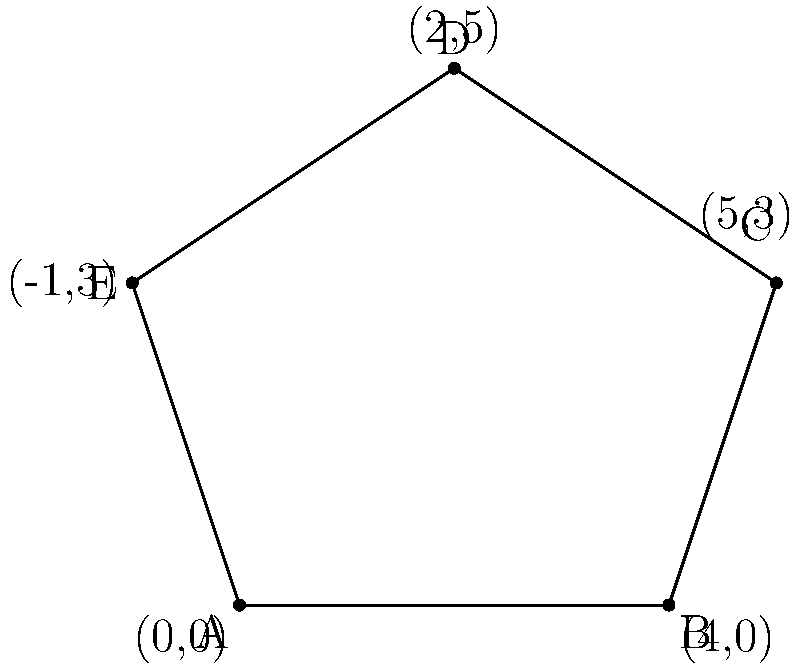In Shakespeare's Sonnet 18, each stanza is represented by a point on a coordinate plane, forming a pentagon. Given the vertices A(0,0), B(4,0), C(5,3), D(2,5), and E(-1,3), which point corresponds to the line "Shall I compare thee to a summer's day?" To solve this problem, let's follow these steps:

1) First, recall that Sonnet 18 consists of three quatrains and a couplet, totaling 14 lines.

2) The opening line "Shall I compare thee to a summer's day?" is the first line of the first quatrain.

3) In a pentagon, there are five vertices, each representing a stanza or significant part of the sonnet:
   - A(0,0): Could represent the beginning, thus the first quatrain
   - B(4,0): Might represent the second quatrain
   - C(5,3): Could be the third quatrain
   - D(2,5): Might represent the volta or turn in the sonnet
   - E(-1,3): Could represent the closing couplet

4) Since we're looking for the point corresponding to the opening line, which is in the first quatrain, we should choose the point that represents the beginning of the sonnet.

5) The point A(0,0) is at the origin of the coordinate system, symbolizing the start or beginning.

Therefore, the point A(0,0) most likely corresponds to the line "Shall I compare thee to a summer's day?"
Answer: A(0,0) 